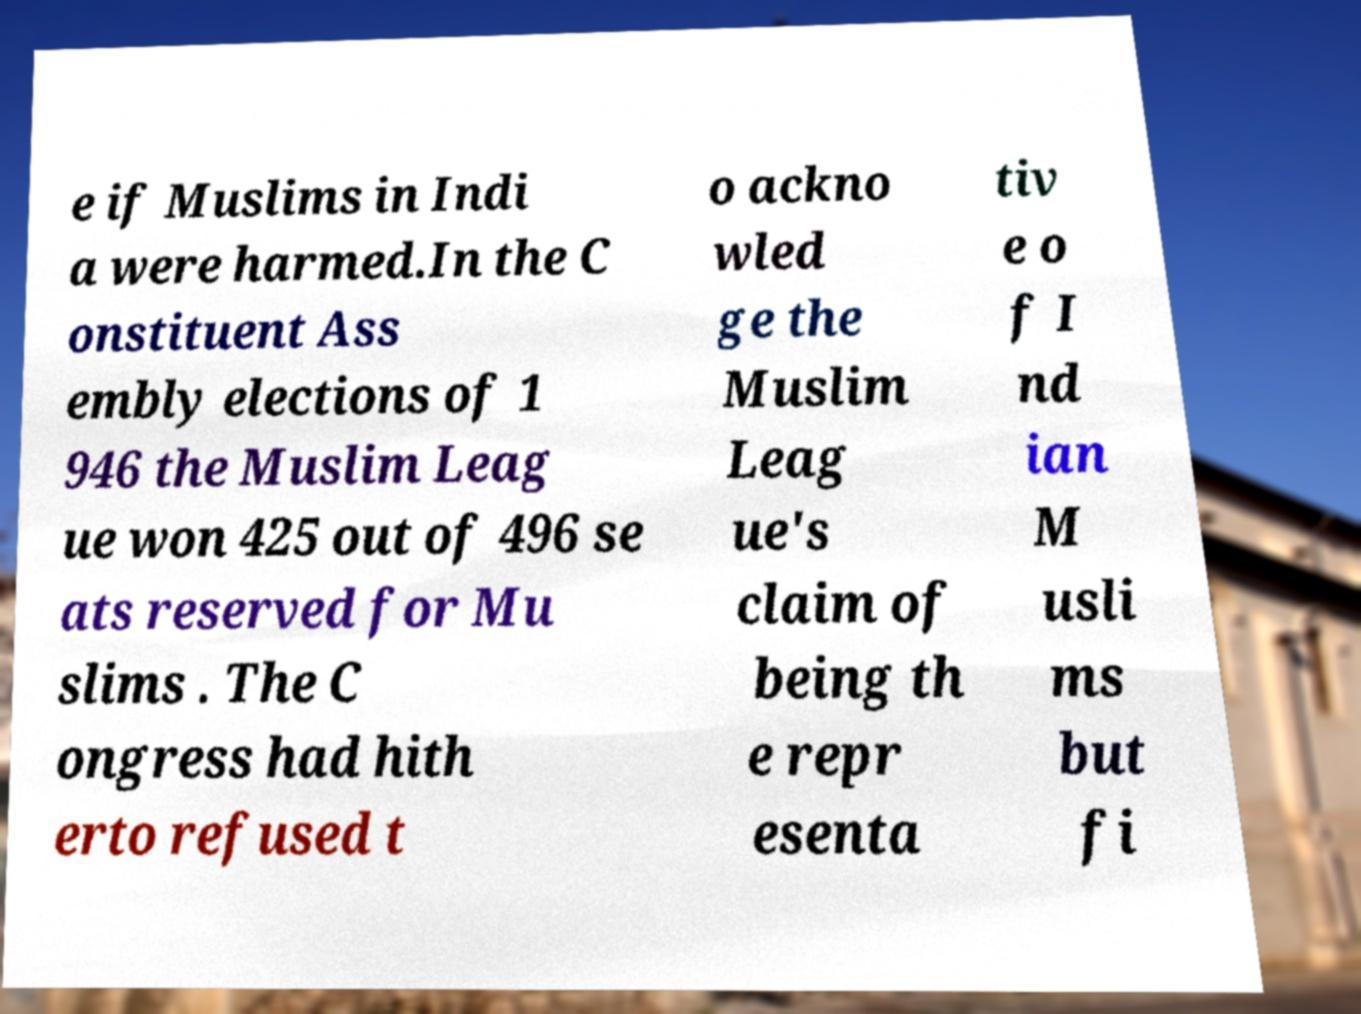Please read and relay the text visible in this image. What does it say? e if Muslims in Indi a were harmed.In the C onstituent Ass embly elections of 1 946 the Muslim Leag ue won 425 out of 496 se ats reserved for Mu slims . The C ongress had hith erto refused t o ackno wled ge the Muslim Leag ue's claim of being th e repr esenta tiv e o f I nd ian M usli ms but fi 